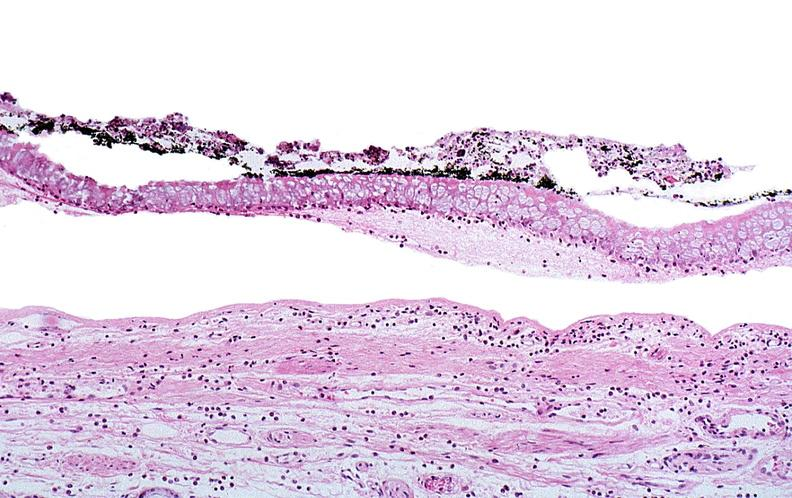what does this image show?
Answer the question using a single word or phrase. Thermal burned skin 